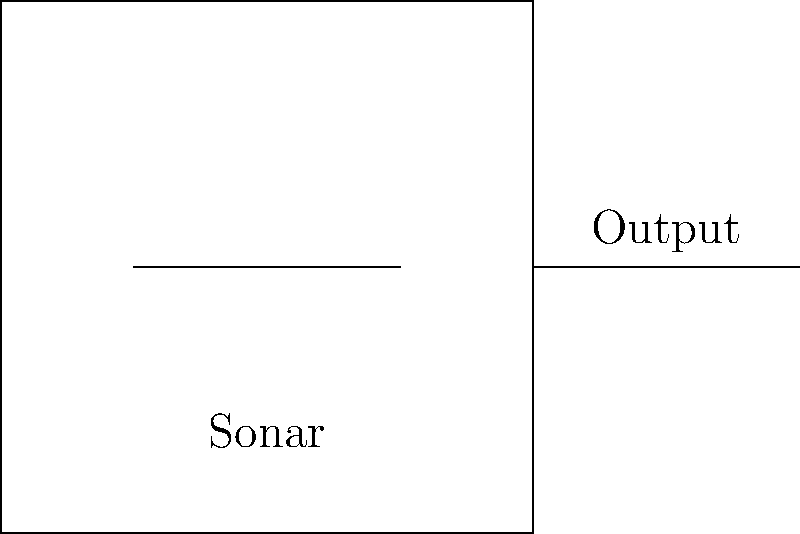Your sonar system on the fishing boat is malfunctioning, producing inconsistent readings. The circuit diagram and signal output are shown above. What could be causing the erratic behavior in the sonar output? To troubleshoot the malfunctioning sonar system, let's analyze the problem step-by-step:

1. Examine the circuit diagram:
   The diagram shows a simplified sonar circuit with an output.

2. Analyze the signal output graph:
   The graph shows a sinusoidal wave with random fluctuations.

3. Identify the abnormal pattern:
   The signal output should be a clean sine wave for normal sonar operation. The presence of random fluctuations indicates noise in the system.

4. Consider possible causes:
   a) Electrical interference from other onboard equipment
   b) Poor grounding of the sonar system
   c) Damaged or loose wiring
   d) Faulty components in the sonar circuit
   e) Environmental factors like turbulent water or school of fish

5. Evaluate the most likely cause:
   Given the random nature of the fluctuations and the marine environment, the most probable cause is electrical interference from other onboard equipment or poor grounding.

6. Propose a solution:
   Improve the shielding of the sonar system and check the grounding connections to reduce electrical noise.
Answer: Electrical interference or poor grounding 